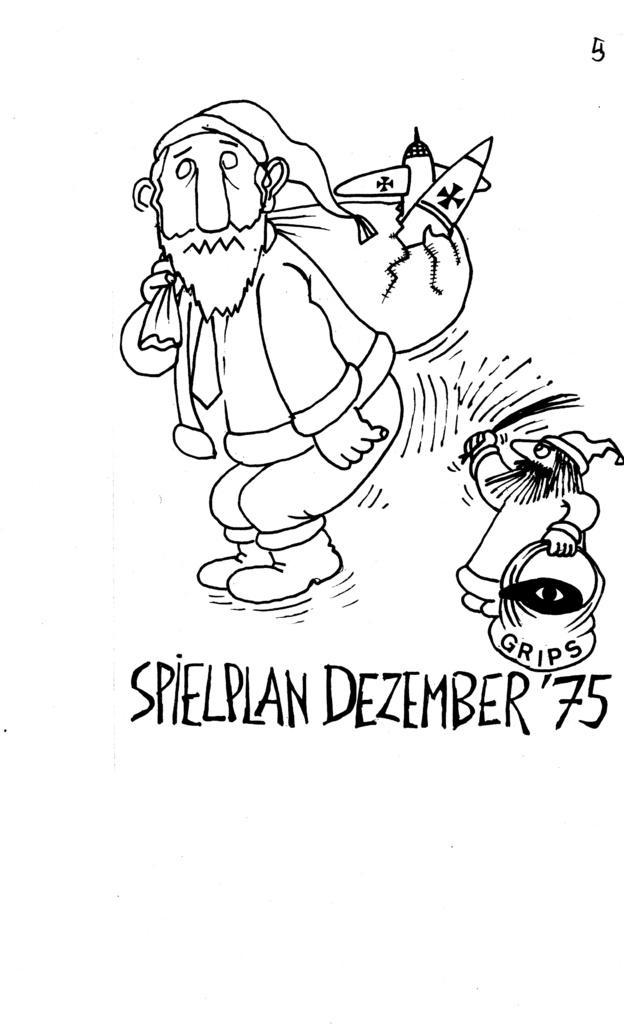In one or two sentences, can you explain what this image depicts? In this image I can see sketch of two cartoons and I can see both of them are carrying bags. I can also see something is written over here. 